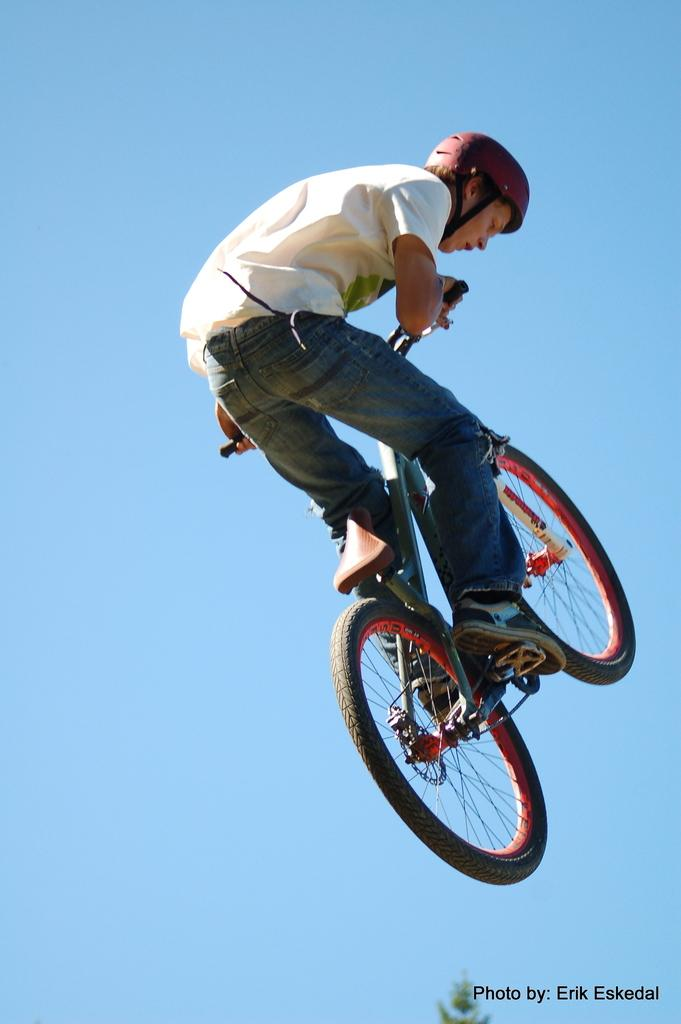What is the main subject of the image? The main subject of the image is a man. What is the man wearing? The man is wearing a t-shirt, trousers, and shoes. What activity is the man engaged in? The man is riding a bicycle. What can be seen in the background of the image? There is a sky visible in the background of the image. How many clocks are hanging on the side of the man in the image? There are no clocks visible in the image, and the man is not shown with any clocks hanging on his side. 